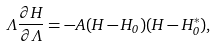<formula> <loc_0><loc_0><loc_500><loc_500>\Lambda \frac { \partial H } { \partial \Lambda } = - A ( H - H _ { 0 } ) ( H - H _ { 0 } ^ { * } ) ,</formula> 